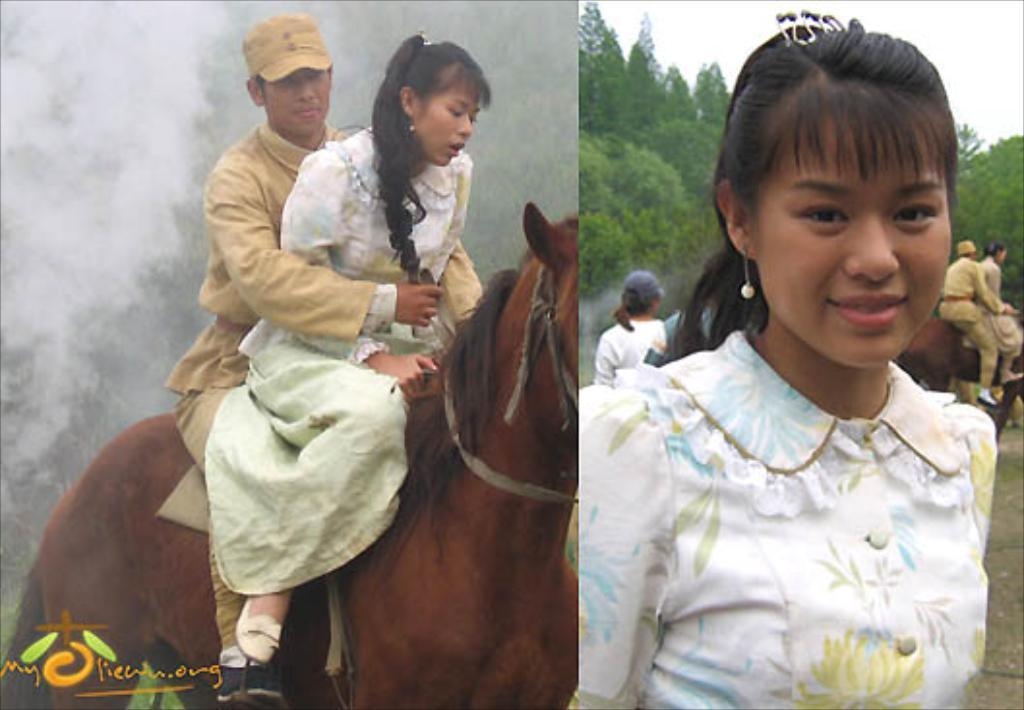How many people are in the image? There are three people in the image: a woman, a man, and a person standing. What are the woman and the man doing in the image? The woman and the man are sitting on a horse. What can be seen in the background of the image? There is a tree and the sky visible in the image. What is the position of the person standing in the image? The person standing is likely near the horse, but the exact position cannot be determined from the provided facts. What type of cushion is being used to support the pan during the feast in the image? There is no cushion, pan, or feast present in the image. 